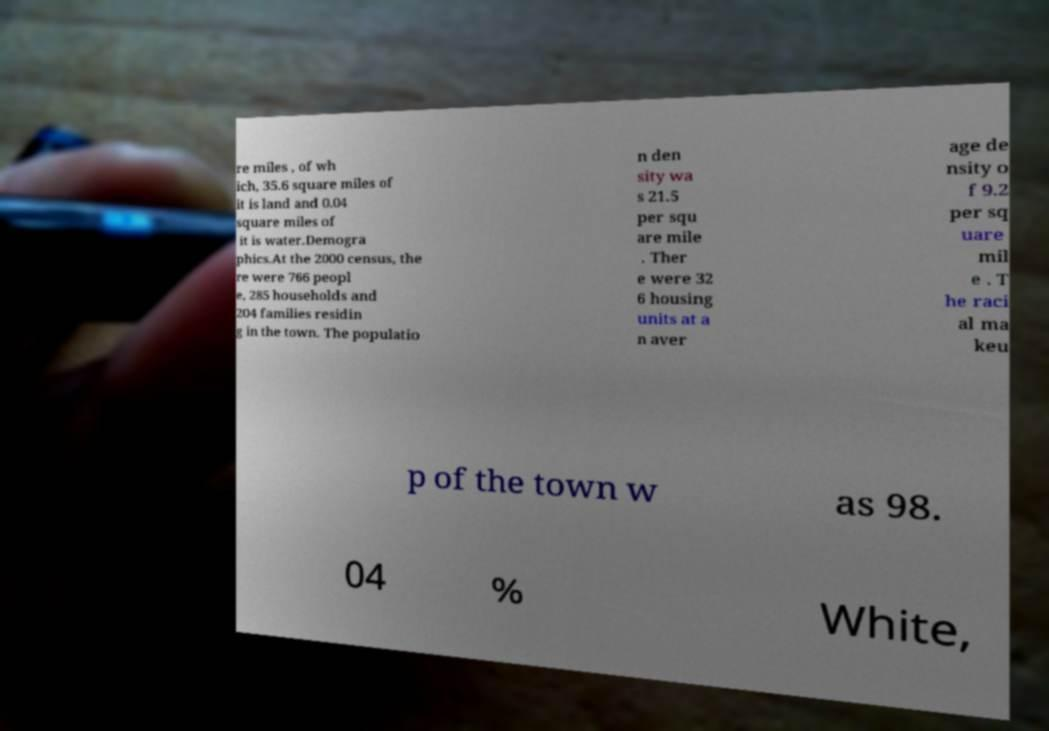Can you accurately transcribe the text from the provided image for me? re miles , of wh ich, 35.6 square miles of it is land and 0.04 square miles of it is water.Demogra phics.At the 2000 census, the re were 766 peopl e, 285 households and 204 families residin g in the town. The populatio n den sity wa s 21.5 per squ are mile . Ther e were 32 6 housing units at a n aver age de nsity o f 9.2 per sq uare mil e . T he raci al ma keu p of the town w as 98. 04 % White, 